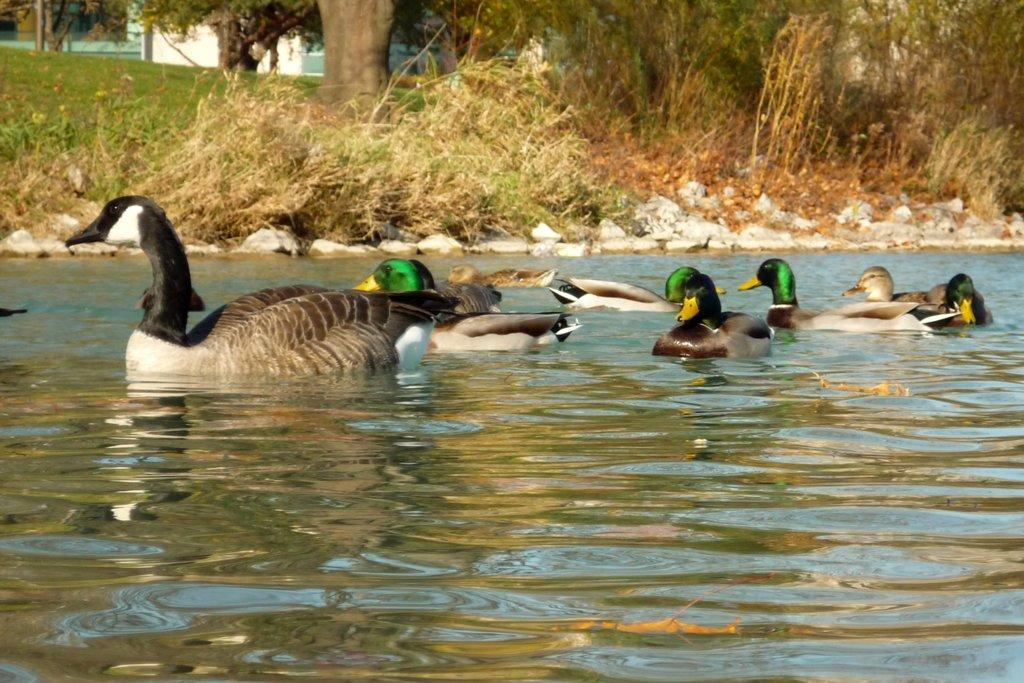What animals are present in the image? There are ducks in the image. What is the ducks' relationship with the water in the image? The ducks are partially in the water. What are the ducks doing in the image? The ducks are swimming. What can be seen in the background of the image? There are rocks, plants, trees, a building, and grass in the background of the image. What color is the monkey in the image? There is no monkey present in the image. How many times do the ducks push each other in the image? The ducks are not shown pushing each other in the image. 